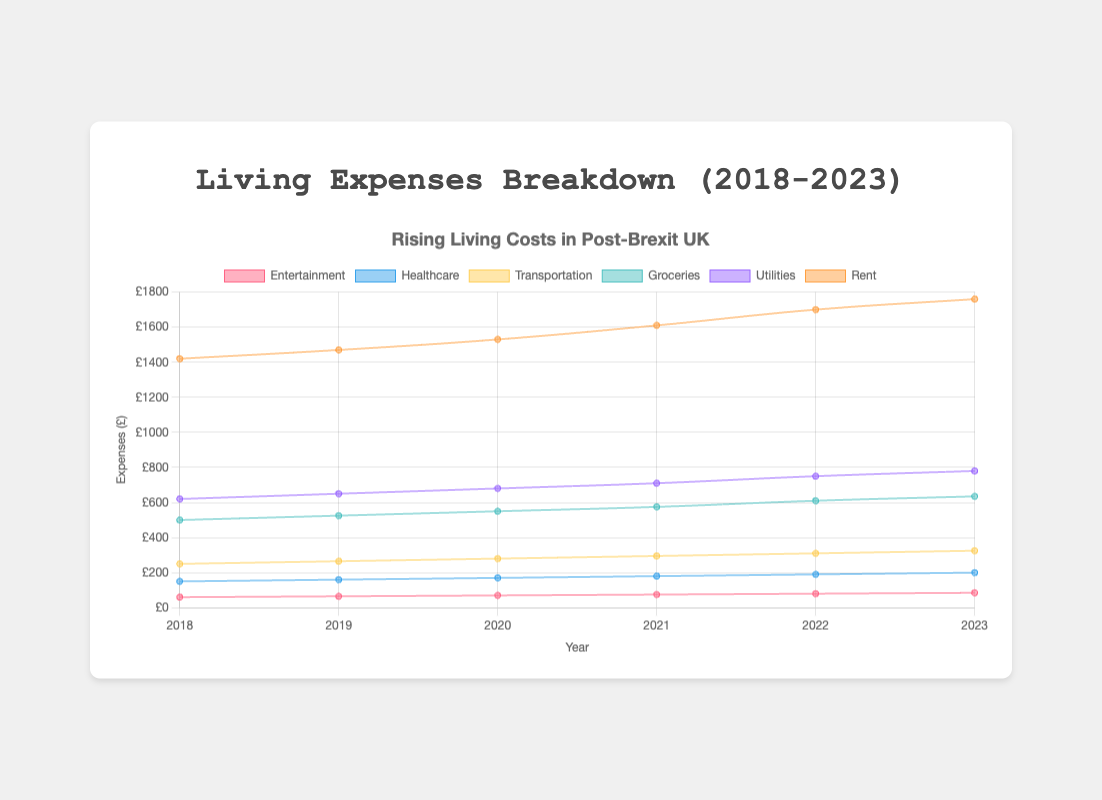What is the title of the chart? The title is located at the top-center of the chart and reads "Rising Living Costs in Post-Brexit UK."
Answer: Rising Living Costs in Post-Brexit UK What is the largest single category of living expenses in 2023? The largest single category can be identified by looking for the highest value on the Y-axis in 2023, which is the 'rent' at £980.
Answer: Rent How much did groceries cost in 2020? The groceries expense for 2020 can be identified by the value on the Y-axis at the point corresponding to the 'groceries' dataset in 2020, which is £270.
Answer: £270 By how much did rent increase between 2018 and 2023? Find the rent values for 2018 and 2023 (800 and 980, respectively), then subtract the former from the latter: £980 - £800 = £180.
Answer: £180 Which category saw the smallest increase in costs between 2018 and 2023? Each category's increase can be calculated, and the smallest can be identified by comparing these: healthcare (115-90=25), utilities (145-120=25), transportation (125-100=25), groceries (310-250=60), entertainment (85-60=25). All smallest increases are the same at £25.
Answer: Healthcare, Utilities, Transportation, Entertainment What is the total of all expenses in 2022? Add the values for all categories in 2022: £950 (rent) + £140 (utilities) + £300 (groceries) + £120 (transportation) + £110 (healthcare) + £80 (entertainment) = £1700.
Answer: £1700 Which year had the lowest total expenses? Sum the expenses for each year and compare: 2018 (1420), 2019 (1465), 2020 (1530), 2021 (1615), 2022 (1700), 2023 (1755). The lowest total is in 2018.
Answer: 2018 What was the average yearly expense for utilities from 2018 to 2023? Add the utilities expenses for each year and divide by the number of years: (120 + 125 + 130 + 135 + 140 + 145) / 6 = 795 / 6 = 132.5.
Answer: £132.5 How have transportation expenses changed over the years 2018 to 2023? Analyze the transportation values year by year: 2018 (100), 2019 (105), 2020 (110), 2021 (115), 2022 (120), 2023 (125). It shows a steady increase each year by £5.
Answer: Steady increase Which category's expenses intersect with another category, and between which years do they intersect? The utilities expenses intersect the transportation expenses. Looking at the trend lines, this intersection happens between 2021 and 2022.
Answer: Utilities and Transportation, between 2021 and 2022 